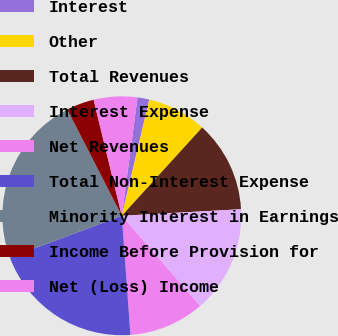Convert chart. <chart><loc_0><loc_0><loc_500><loc_500><pie_chart><fcel>Interest<fcel>Other<fcel>Total Revenues<fcel>Interest Expense<fcel>Net Revenues<fcel>Total Non-Interest Expense<fcel>Minority Interest in Earnings<fcel>Income Before Provision for<fcel>Net (Loss) Income<nl><fcel>1.59%<fcel>8.06%<fcel>12.37%<fcel>14.52%<fcel>10.21%<fcel>20.47%<fcel>23.14%<fcel>3.75%<fcel>5.9%<nl></chart> 